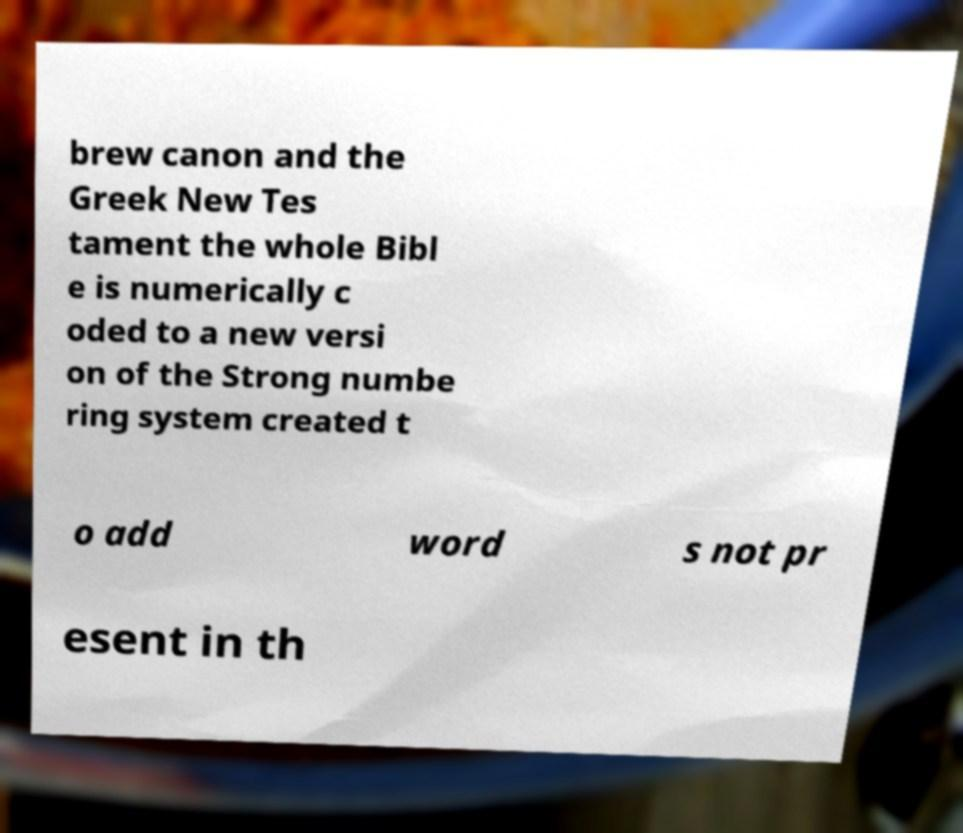Could you assist in decoding the text presented in this image and type it out clearly? brew canon and the Greek New Tes tament the whole Bibl e is numerically c oded to a new versi on of the Strong numbe ring system created t o add word s not pr esent in th 